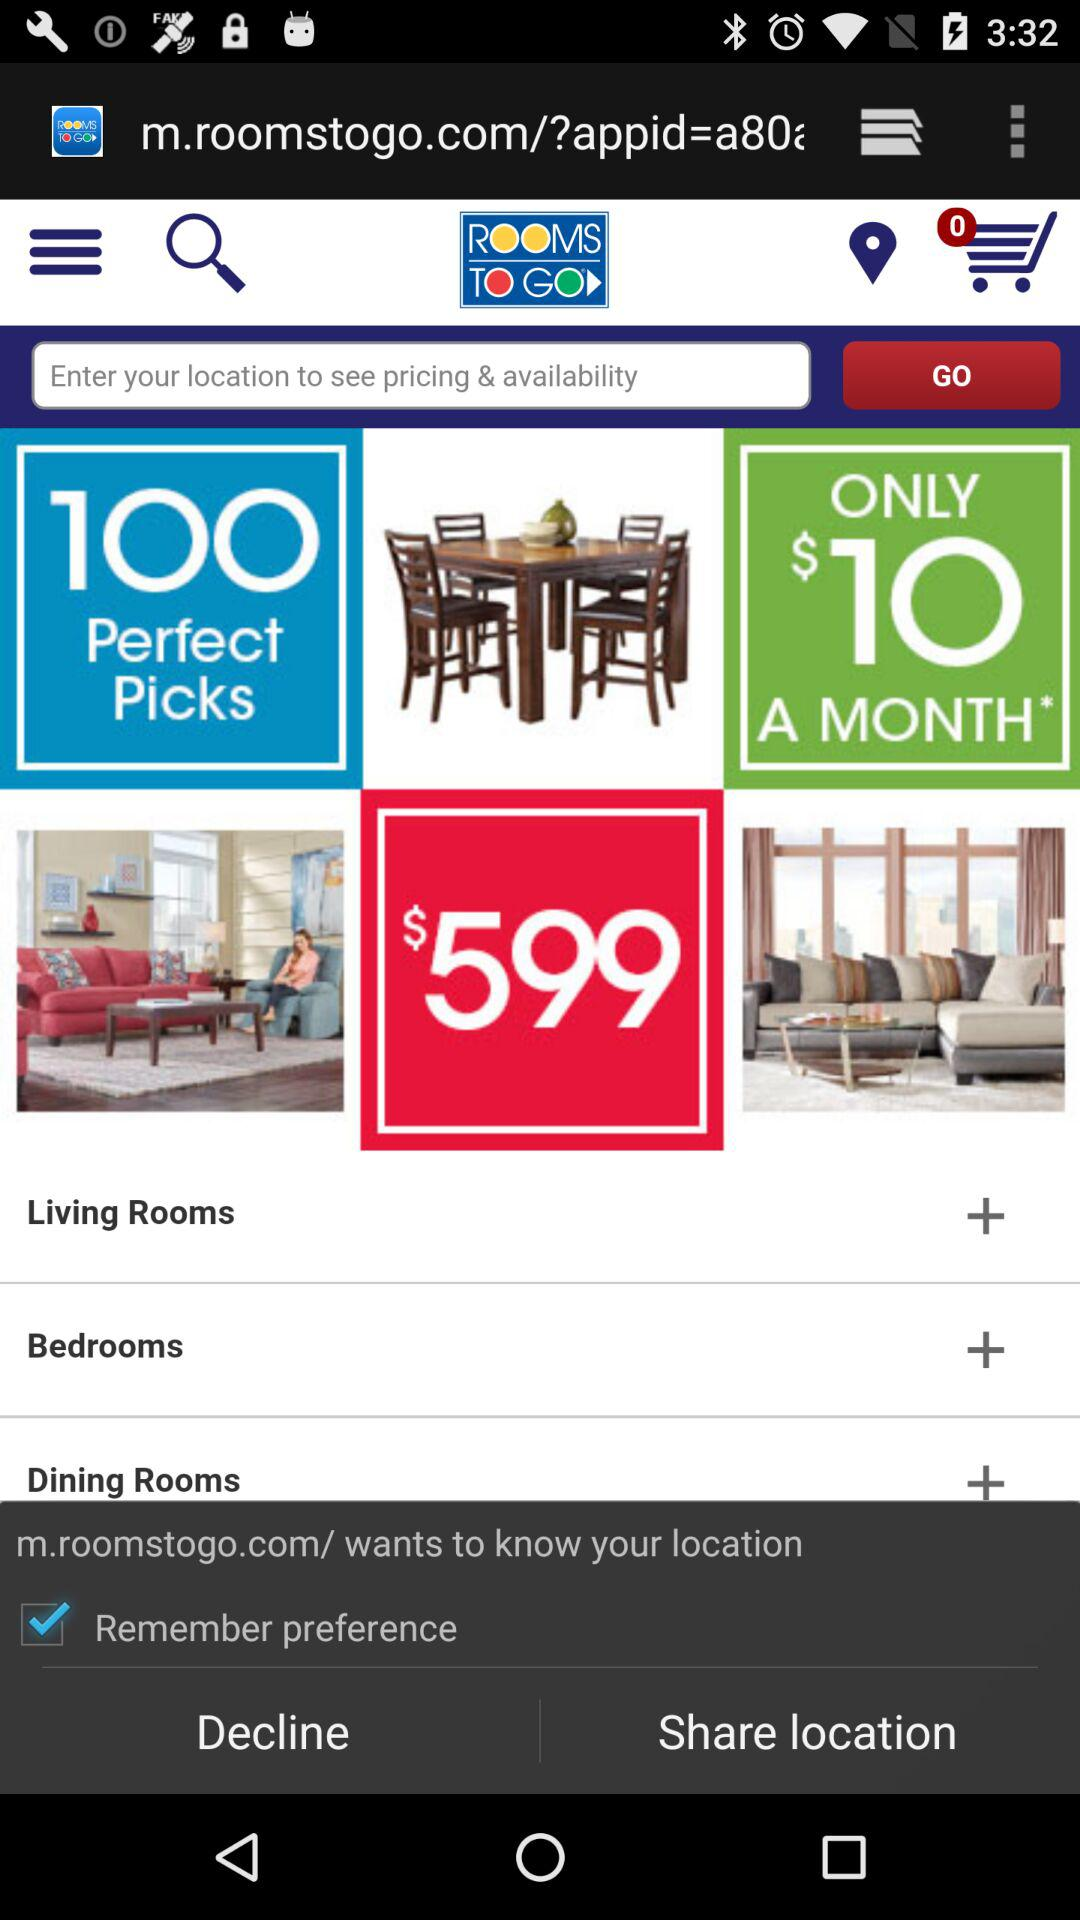What is the number of items in the cart? There are 0 items in the cart. 